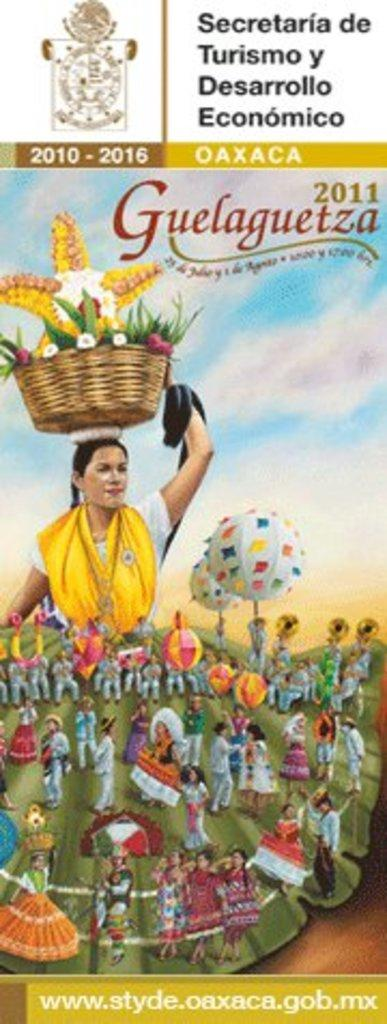What is present in the image that contains both images and text? There is a poster in the image that contains images and text. What type of door is depicted in the poster? There is no door present in the image, as the main subject is a poster containing images and text. 